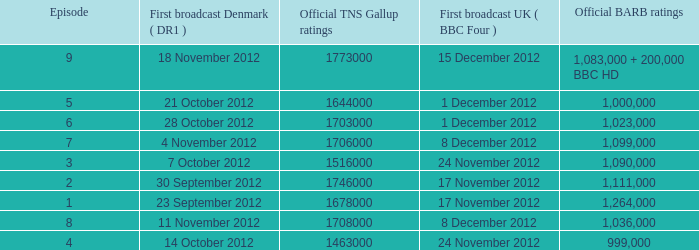When was the episode with a 1,036,000 BARB rating first aired in Denmark? 11 November 2012. 